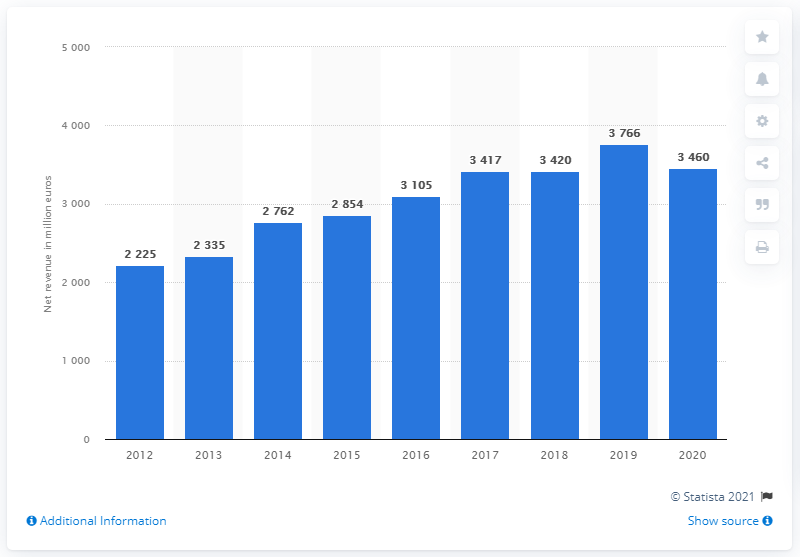Point out several critical features in this image. Ferrari's net revenue in the 2020 fiscal year was 3,460 million euros. 